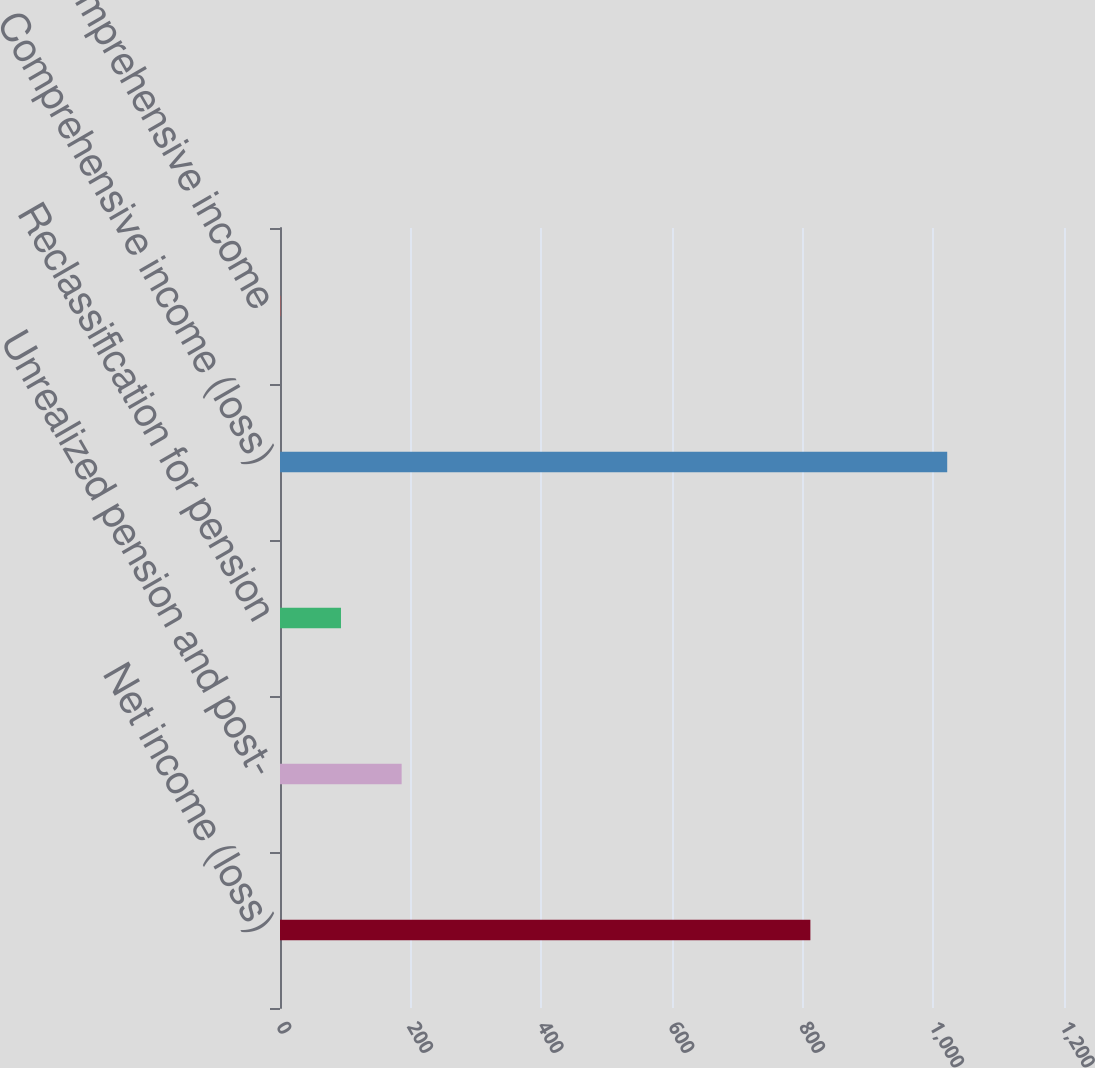Convert chart. <chart><loc_0><loc_0><loc_500><loc_500><bar_chart><fcel>Net income (loss)<fcel>Unrealized pension and post-<fcel>Reclassification for pension<fcel>Comprehensive income (loss)<fcel>Comprehensive income<nl><fcel>811.8<fcel>186.18<fcel>93.34<fcel>1021.24<fcel>0.5<nl></chart> 